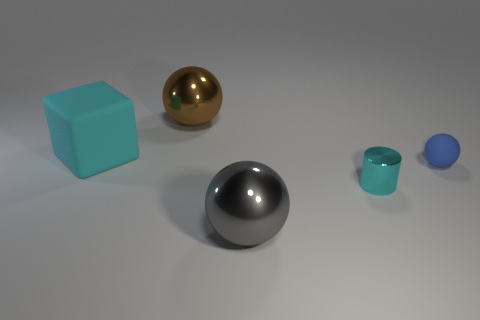Subtract all big spheres. How many spheres are left? 1 Add 3 large gray shiny spheres. How many objects exist? 8 Subtract all blue balls. How many balls are left? 2 Subtract all blue cylinders. How many cyan spheres are left? 0 Subtract all cyan metallic cylinders. Subtract all big shiny things. How many objects are left? 2 Add 1 metallic cylinders. How many metallic cylinders are left? 2 Add 3 big gray rubber things. How many big gray rubber things exist? 3 Subtract 0 blue cylinders. How many objects are left? 5 Subtract all balls. How many objects are left? 2 Subtract 1 balls. How many balls are left? 2 